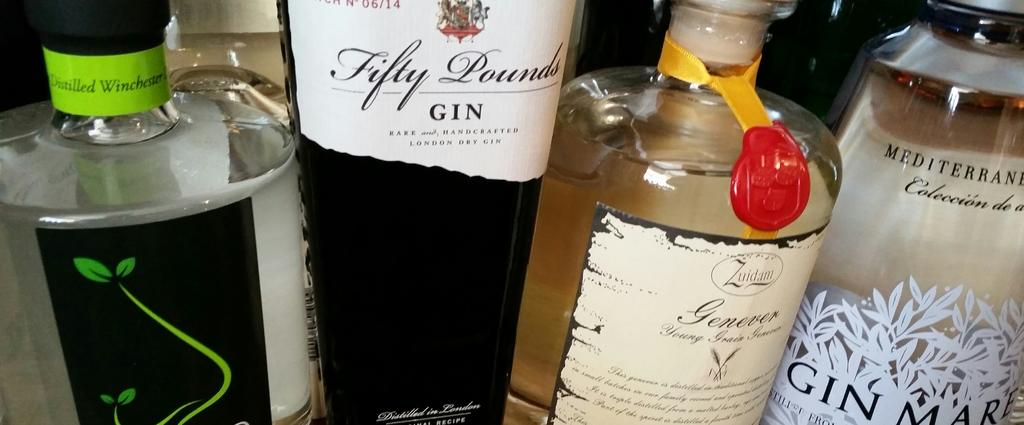What type of objects can be seen in the image? There are four alcohol bottles in the image. How are the bottles arranged in the image? The bottles are arranged in a row. What type of soup is being prepared in the image? There is no soup present in the image; it only features four alcohol bottles arranged in a row. 